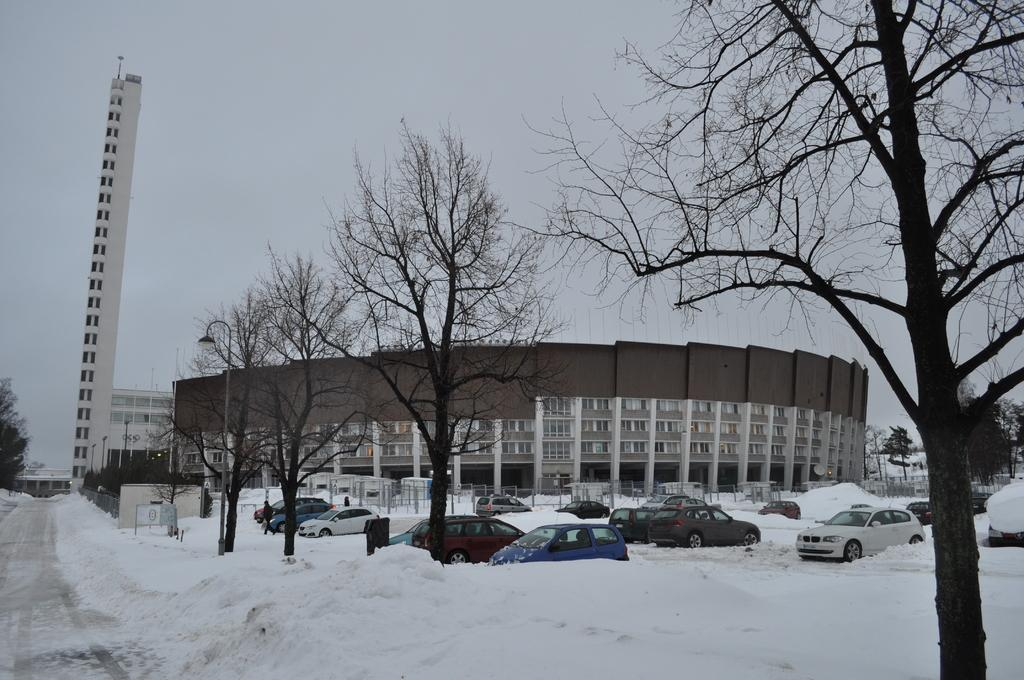What is the condition of the ground in the image? There is snow on the ground in the image. What type of trees can be seen in the center of the image? There are dry trees in the center of the image. What can be seen in the background of the image? Cars, buildings, and trees are visible in the background of the image. What is the condition of the sky in the image? The sky is cloudy in the image. What type of humor can be seen in the image? There is no humor present in the image; it depicts a snowy scene with dry trees and cars in the background. What type of plantation is visible in the image? There is no plantation present in the image; it shows a snowy landscape with dry trees and cars in the background. 